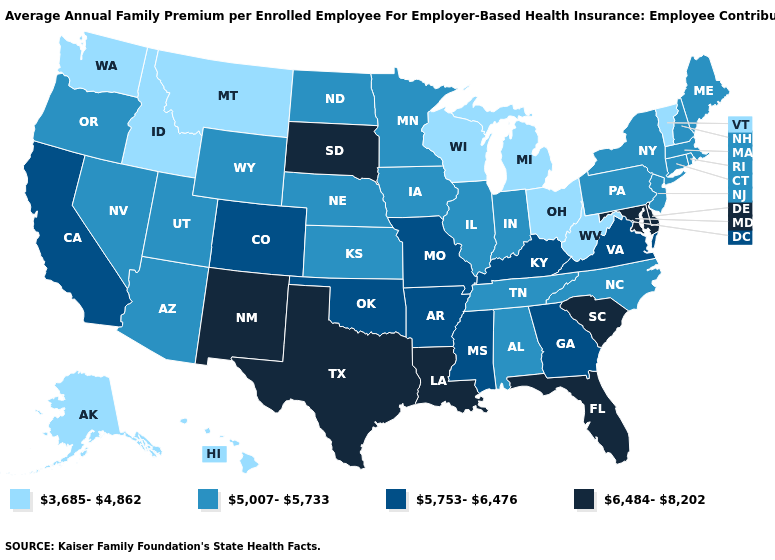What is the value of Missouri?
Keep it brief. 5,753-6,476. How many symbols are there in the legend?
Concise answer only. 4. How many symbols are there in the legend?
Answer briefly. 4. What is the value of Connecticut?
Give a very brief answer. 5,007-5,733. Name the states that have a value in the range 5,753-6,476?
Keep it brief. Arkansas, California, Colorado, Georgia, Kentucky, Mississippi, Missouri, Oklahoma, Virginia. Does Mississippi have the highest value in the USA?
Concise answer only. No. Name the states that have a value in the range 3,685-4,862?
Keep it brief. Alaska, Hawaii, Idaho, Michigan, Montana, Ohio, Vermont, Washington, West Virginia, Wisconsin. What is the value of Wisconsin?
Be succinct. 3,685-4,862. Name the states that have a value in the range 3,685-4,862?
Keep it brief. Alaska, Hawaii, Idaho, Michigan, Montana, Ohio, Vermont, Washington, West Virginia, Wisconsin. Does the map have missing data?
Quick response, please. No. Which states have the lowest value in the USA?
Quick response, please. Alaska, Hawaii, Idaho, Michigan, Montana, Ohio, Vermont, Washington, West Virginia, Wisconsin. Does Mississippi have a lower value than South Dakota?
Be succinct. Yes. What is the highest value in states that border Arizona?
Keep it brief. 6,484-8,202. Does the map have missing data?
Be succinct. No. What is the value of Maryland?
Short answer required. 6,484-8,202. 